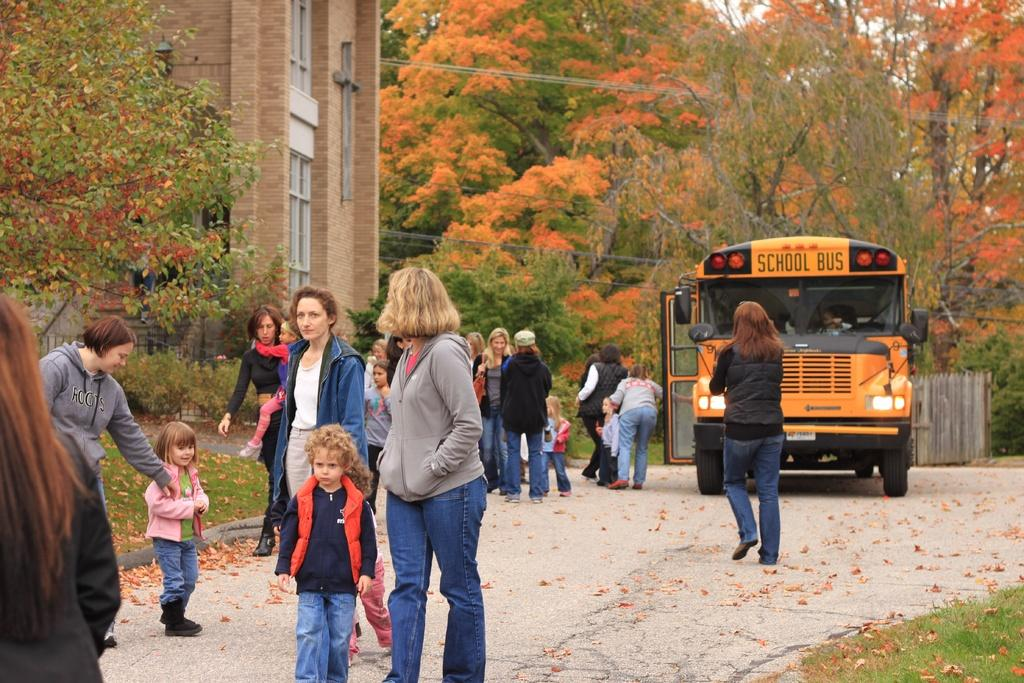What is happening on the road in the image? There are people on the road in the image. What is behind the people on the road? There is a school bus behind the people. What type of vegetation is present around the people? Grass is present around the people. What else can be seen in the image besides the people and the school bus? Trees and a building are visible in the image. Can you tell me how many daughters are visible in the image? There is no mention of a daughter or any children in the image. Is there a gun present in the image? There is no gun visible in the image. 